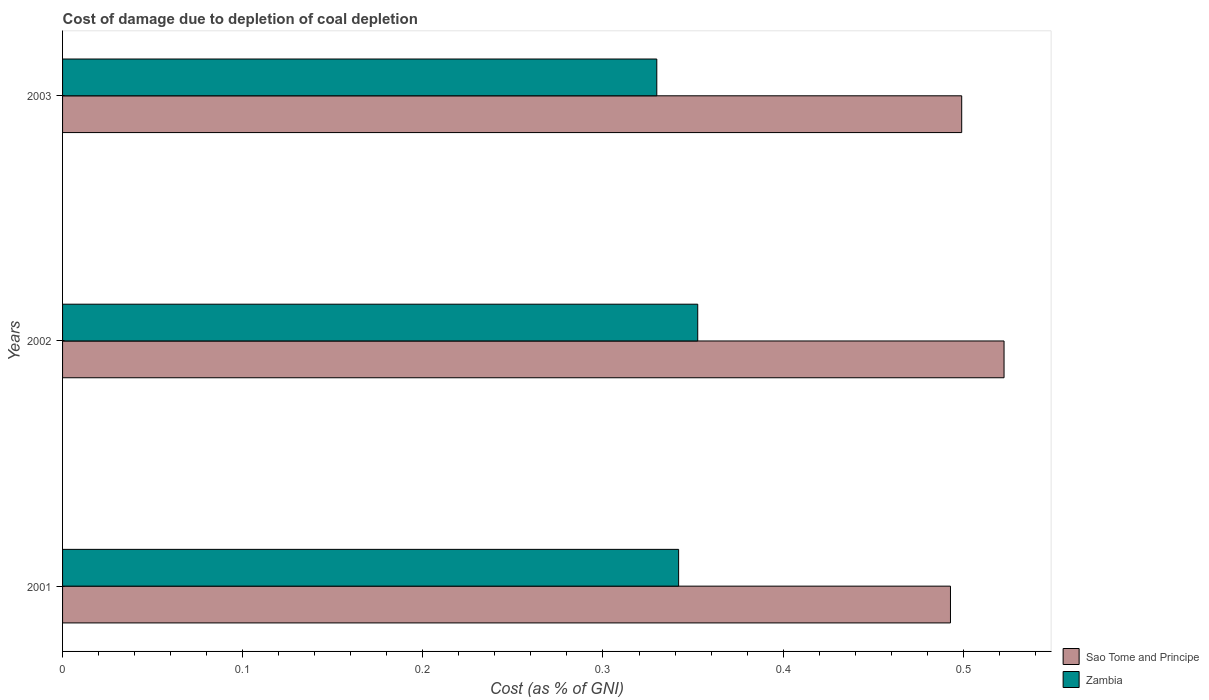Are the number of bars on each tick of the Y-axis equal?
Keep it short and to the point. Yes. What is the cost of damage caused due to coal depletion in Zambia in 2002?
Your answer should be very brief. 0.35. Across all years, what is the maximum cost of damage caused due to coal depletion in Sao Tome and Principe?
Give a very brief answer. 0.52. Across all years, what is the minimum cost of damage caused due to coal depletion in Sao Tome and Principe?
Your answer should be very brief. 0.49. In which year was the cost of damage caused due to coal depletion in Sao Tome and Principe maximum?
Provide a short and direct response. 2002. What is the total cost of damage caused due to coal depletion in Sao Tome and Principe in the graph?
Provide a short and direct response. 1.51. What is the difference between the cost of damage caused due to coal depletion in Zambia in 2002 and that in 2003?
Ensure brevity in your answer.  0.02. What is the difference between the cost of damage caused due to coal depletion in Zambia in 2001 and the cost of damage caused due to coal depletion in Sao Tome and Principe in 2002?
Your answer should be very brief. -0.18. What is the average cost of damage caused due to coal depletion in Sao Tome and Principe per year?
Provide a succinct answer. 0.5. In the year 2003, what is the difference between the cost of damage caused due to coal depletion in Zambia and cost of damage caused due to coal depletion in Sao Tome and Principe?
Your answer should be very brief. -0.17. What is the ratio of the cost of damage caused due to coal depletion in Zambia in 2002 to that in 2003?
Ensure brevity in your answer.  1.07. Is the cost of damage caused due to coal depletion in Sao Tome and Principe in 2001 less than that in 2002?
Ensure brevity in your answer.  Yes. Is the difference between the cost of damage caused due to coal depletion in Zambia in 2002 and 2003 greater than the difference between the cost of damage caused due to coal depletion in Sao Tome and Principe in 2002 and 2003?
Ensure brevity in your answer.  No. What is the difference between the highest and the second highest cost of damage caused due to coal depletion in Sao Tome and Principe?
Give a very brief answer. 0.02. What is the difference between the highest and the lowest cost of damage caused due to coal depletion in Sao Tome and Principe?
Your response must be concise. 0.03. In how many years, is the cost of damage caused due to coal depletion in Sao Tome and Principe greater than the average cost of damage caused due to coal depletion in Sao Tome and Principe taken over all years?
Your response must be concise. 1. Is the sum of the cost of damage caused due to coal depletion in Sao Tome and Principe in 2002 and 2003 greater than the maximum cost of damage caused due to coal depletion in Zambia across all years?
Offer a terse response. Yes. What does the 2nd bar from the top in 2003 represents?
Your answer should be compact. Sao Tome and Principe. What does the 1st bar from the bottom in 2002 represents?
Ensure brevity in your answer.  Sao Tome and Principe. How many bars are there?
Ensure brevity in your answer.  6. Are all the bars in the graph horizontal?
Provide a succinct answer. Yes. What is the difference between two consecutive major ticks on the X-axis?
Make the answer very short. 0.1. Does the graph contain grids?
Ensure brevity in your answer.  No. How are the legend labels stacked?
Offer a terse response. Vertical. What is the title of the graph?
Provide a succinct answer. Cost of damage due to depletion of coal depletion. Does "Latin America(developing only)" appear as one of the legend labels in the graph?
Keep it short and to the point. No. What is the label or title of the X-axis?
Your answer should be compact. Cost (as % of GNI). What is the Cost (as % of GNI) of Sao Tome and Principe in 2001?
Make the answer very short. 0.49. What is the Cost (as % of GNI) in Zambia in 2001?
Ensure brevity in your answer.  0.34. What is the Cost (as % of GNI) of Sao Tome and Principe in 2002?
Make the answer very short. 0.52. What is the Cost (as % of GNI) of Zambia in 2002?
Offer a very short reply. 0.35. What is the Cost (as % of GNI) of Sao Tome and Principe in 2003?
Ensure brevity in your answer.  0.5. What is the Cost (as % of GNI) of Zambia in 2003?
Your response must be concise. 0.33. Across all years, what is the maximum Cost (as % of GNI) in Sao Tome and Principe?
Give a very brief answer. 0.52. Across all years, what is the maximum Cost (as % of GNI) of Zambia?
Offer a very short reply. 0.35. Across all years, what is the minimum Cost (as % of GNI) in Sao Tome and Principe?
Provide a succinct answer. 0.49. Across all years, what is the minimum Cost (as % of GNI) in Zambia?
Provide a short and direct response. 0.33. What is the total Cost (as % of GNI) of Sao Tome and Principe in the graph?
Offer a very short reply. 1.51. What is the total Cost (as % of GNI) in Zambia in the graph?
Keep it short and to the point. 1.02. What is the difference between the Cost (as % of GNI) of Sao Tome and Principe in 2001 and that in 2002?
Your response must be concise. -0.03. What is the difference between the Cost (as % of GNI) of Zambia in 2001 and that in 2002?
Provide a succinct answer. -0.01. What is the difference between the Cost (as % of GNI) of Sao Tome and Principe in 2001 and that in 2003?
Provide a succinct answer. -0.01. What is the difference between the Cost (as % of GNI) of Zambia in 2001 and that in 2003?
Ensure brevity in your answer.  0.01. What is the difference between the Cost (as % of GNI) of Sao Tome and Principe in 2002 and that in 2003?
Provide a short and direct response. 0.02. What is the difference between the Cost (as % of GNI) of Zambia in 2002 and that in 2003?
Give a very brief answer. 0.02. What is the difference between the Cost (as % of GNI) in Sao Tome and Principe in 2001 and the Cost (as % of GNI) in Zambia in 2002?
Your response must be concise. 0.14. What is the difference between the Cost (as % of GNI) of Sao Tome and Principe in 2001 and the Cost (as % of GNI) of Zambia in 2003?
Your answer should be compact. 0.16. What is the difference between the Cost (as % of GNI) in Sao Tome and Principe in 2002 and the Cost (as % of GNI) in Zambia in 2003?
Keep it short and to the point. 0.19. What is the average Cost (as % of GNI) in Sao Tome and Principe per year?
Your response must be concise. 0.5. What is the average Cost (as % of GNI) of Zambia per year?
Your answer should be very brief. 0.34. In the year 2001, what is the difference between the Cost (as % of GNI) of Sao Tome and Principe and Cost (as % of GNI) of Zambia?
Provide a succinct answer. 0.15. In the year 2002, what is the difference between the Cost (as % of GNI) of Sao Tome and Principe and Cost (as % of GNI) of Zambia?
Provide a succinct answer. 0.17. In the year 2003, what is the difference between the Cost (as % of GNI) of Sao Tome and Principe and Cost (as % of GNI) of Zambia?
Provide a short and direct response. 0.17. What is the ratio of the Cost (as % of GNI) in Sao Tome and Principe in 2001 to that in 2002?
Your answer should be compact. 0.94. What is the ratio of the Cost (as % of GNI) in Zambia in 2001 to that in 2002?
Your answer should be very brief. 0.97. What is the ratio of the Cost (as % of GNI) in Sao Tome and Principe in 2001 to that in 2003?
Your answer should be very brief. 0.99. What is the ratio of the Cost (as % of GNI) of Zambia in 2001 to that in 2003?
Your answer should be very brief. 1.04. What is the ratio of the Cost (as % of GNI) in Sao Tome and Principe in 2002 to that in 2003?
Keep it short and to the point. 1.05. What is the ratio of the Cost (as % of GNI) in Zambia in 2002 to that in 2003?
Your response must be concise. 1.07. What is the difference between the highest and the second highest Cost (as % of GNI) of Sao Tome and Principe?
Your answer should be compact. 0.02. What is the difference between the highest and the second highest Cost (as % of GNI) of Zambia?
Offer a very short reply. 0.01. What is the difference between the highest and the lowest Cost (as % of GNI) in Sao Tome and Principe?
Your response must be concise. 0.03. What is the difference between the highest and the lowest Cost (as % of GNI) in Zambia?
Your answer should be very brief. 0.02. 